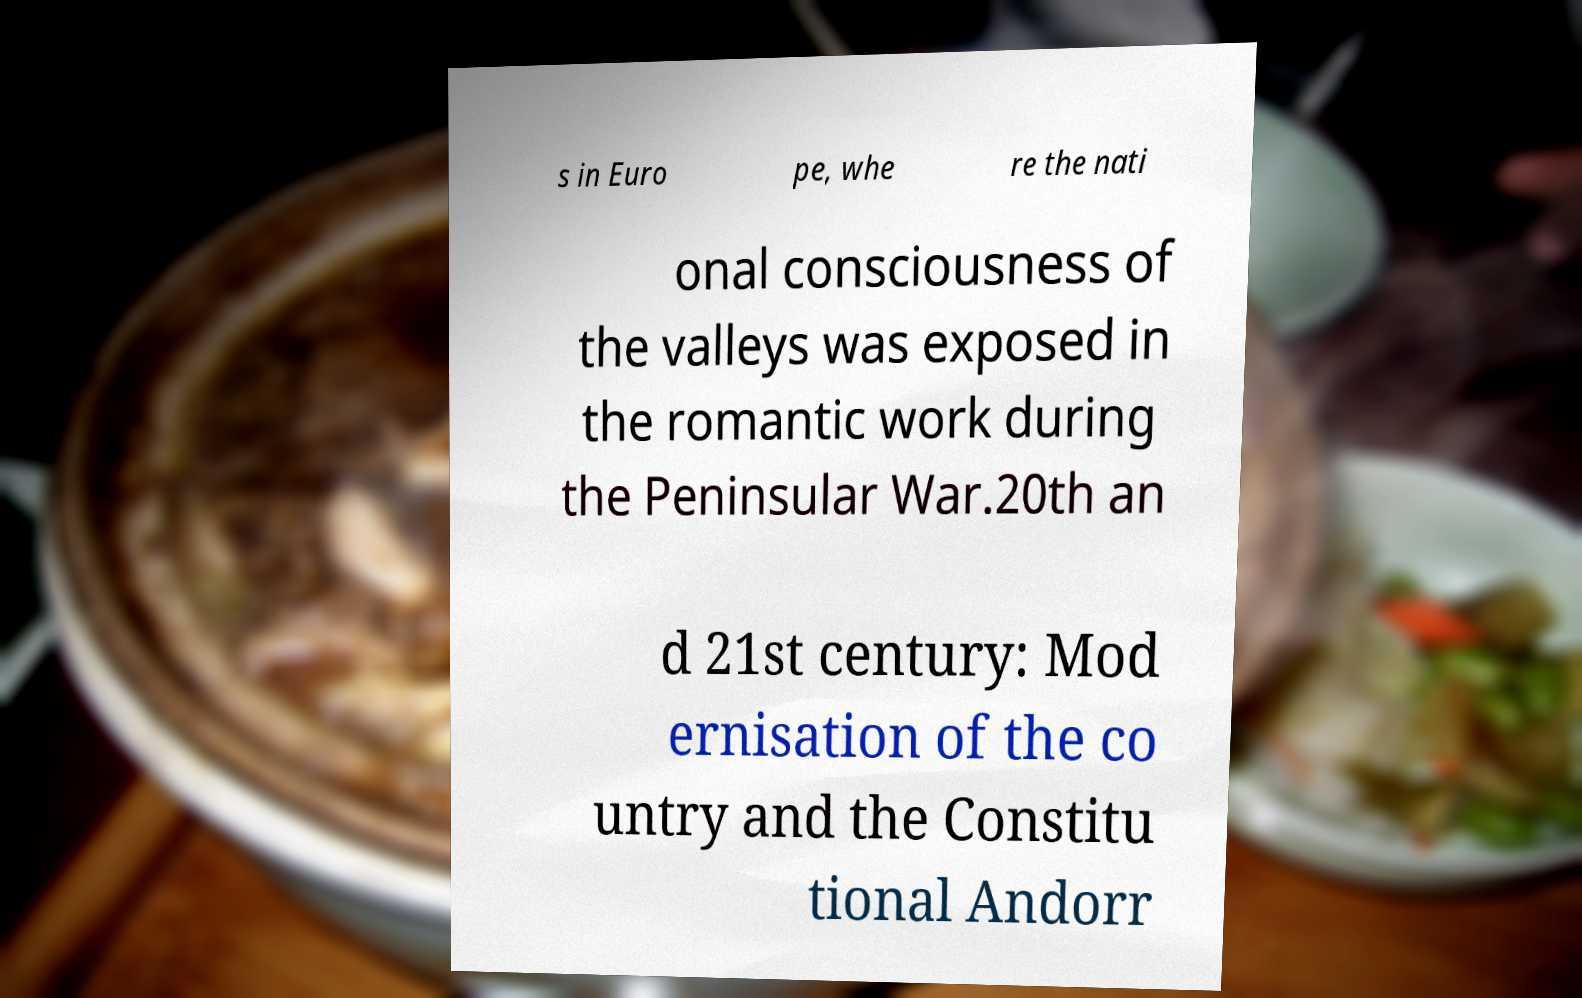Can you read and provide the text displayed in the image?This photo seems to have some interesting text. Can you extract and type it out for me? s in Euro pe, whe re the nati onal consciousness of the valleys was exposed in the romantic work during the Peninsular War.20th an d 21st century: Mod ernisation of the co untry and the Constitu tional Andorr 